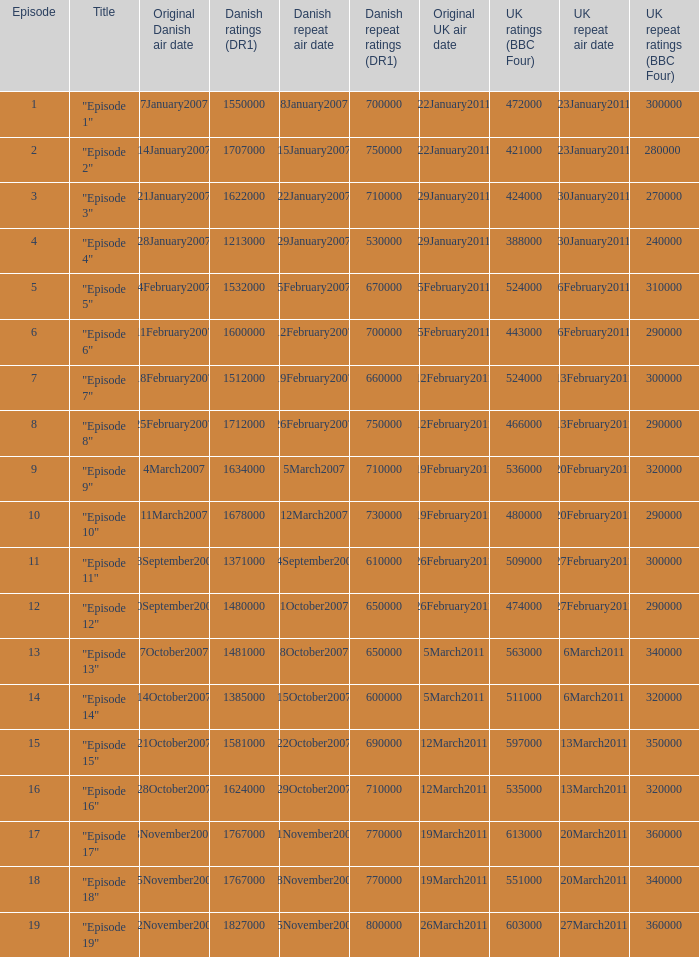What were the UK ratings (BBC Four) for "Episode 17"?  613000.0. 